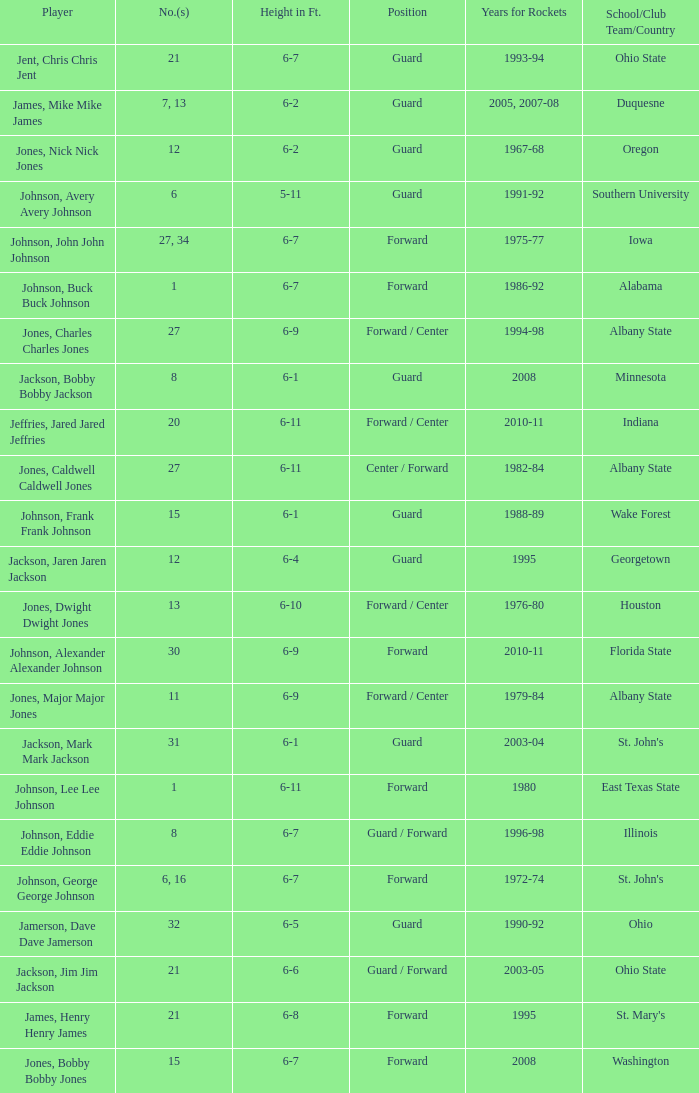What is the number of the player who went to Southern University? 6.0. 